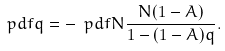<formula> <loc_0><loc_0><loc_500><loc_500>\ p d { f } { q } = - \ p d { f } { N } \frac { N ( 1 - A ) } { 1 - ( 1 - A ) q } .</formula> 